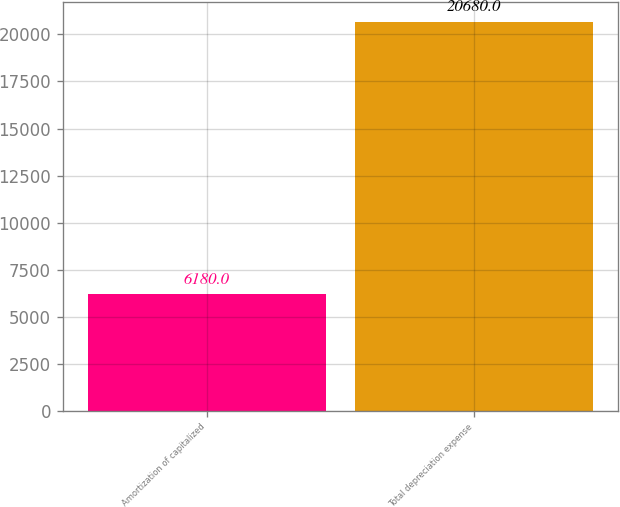<chart> <loc_0><loc_0><loc_500><loc_500><bar_chart><fcel>Amortization of capitalized<fcel>Total depreciation expense<nl><fcel>6180<fcel>20680<nl></chart> 